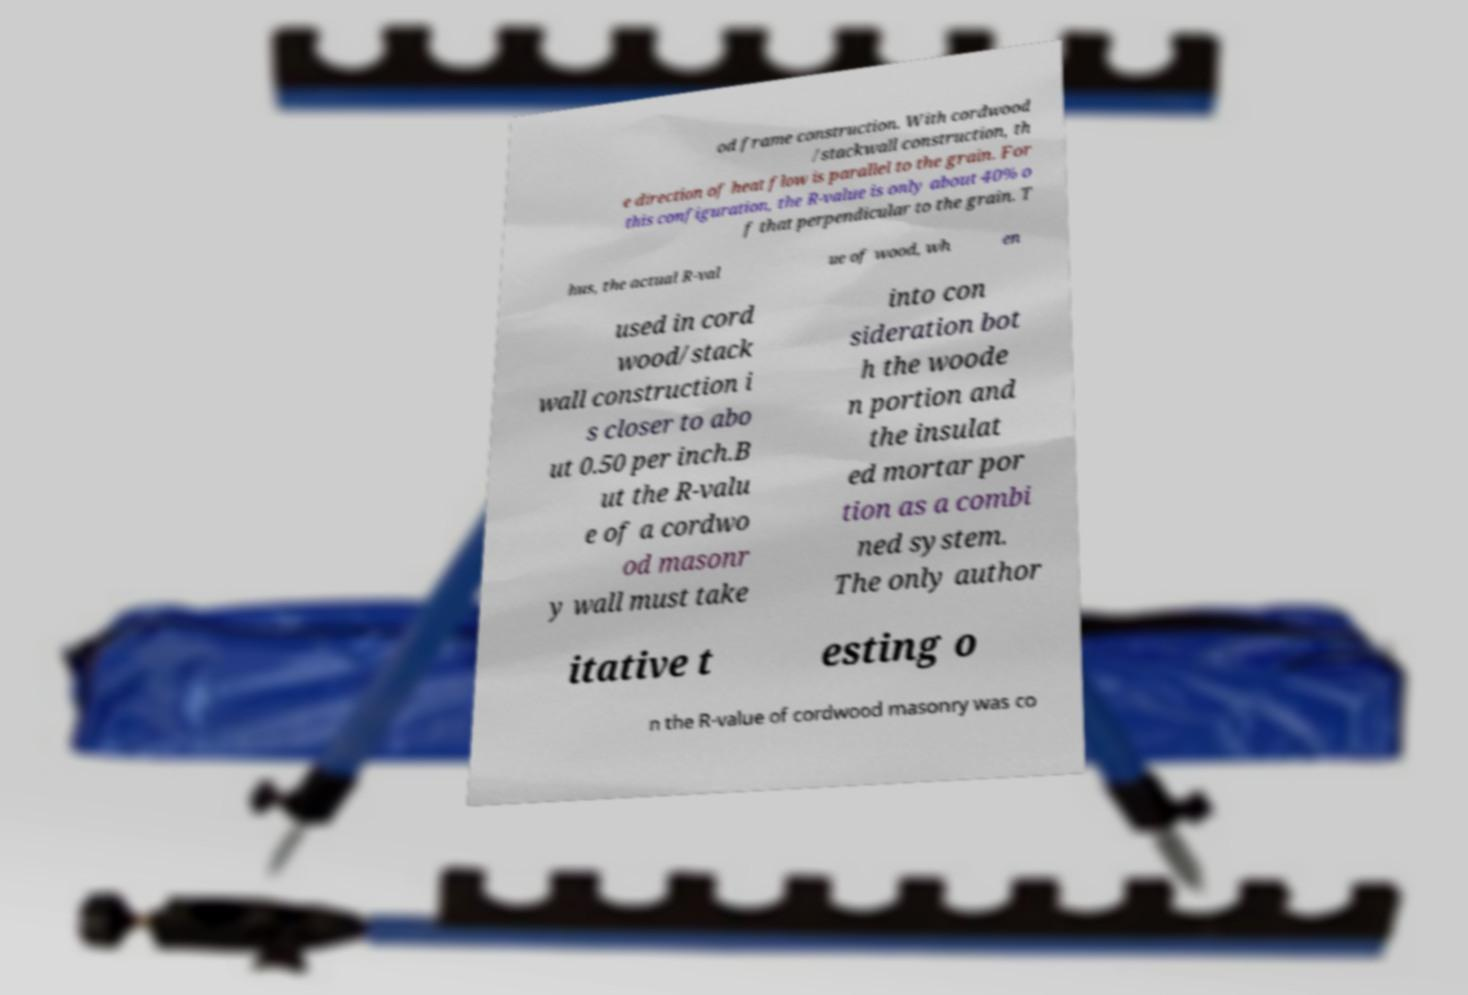Please identify and transcribe the text found in this image. od frame construction. With cordwood /stackwall construction, th e direction of heat flow is parallel to the grain. For this configuration, the R-value is only about 40% o f that perpendicular to the grain. T hus, the actual R-val ue of wood, wh en used in cord wood/stack wall construction i s closer to abo ut 0.50 per inch.B ut the R-valu e of a cordwo od masonr y wall must take into con sideration bot h the woode n portion and the insulat ed mortar por tion as a combi ned system. The only author itative t esting o n the R-value of cordwood masonry was co 